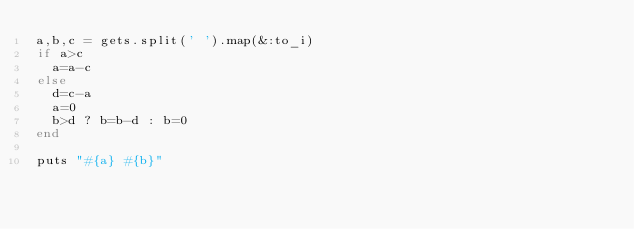<code> <loc_0><loc_0><loc_500><loc_500><_Ruby_>a,b,c = gets.split(' ').map(&:to_i)
if a>c
  a=a-c
else
  d=c-a
  a=0
  b>d ? b=b-d : b=0
end

puts "#{a} #{b}"</code> 